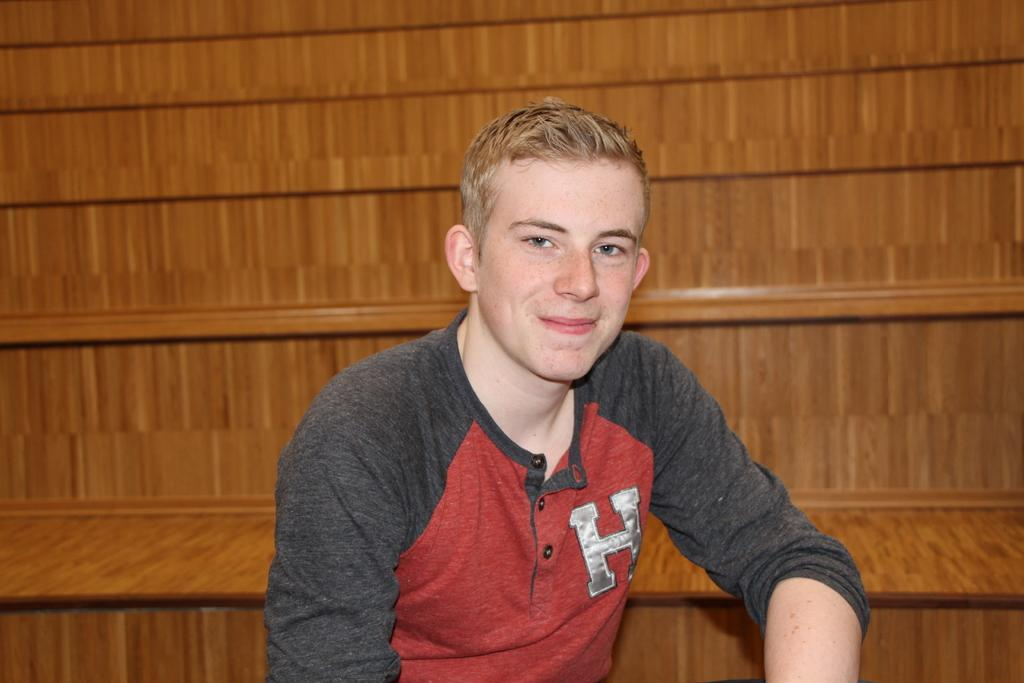What is happening in the image? There is a person in the image who is smiling and posing for a photo. Can you describe the person's expression? The person is smiling in the image. What can be seen in the background of the image? There is a wooden structure in the background of the image that resembles stairs. How many oranges are being held by the person in the image? There are no oranges present in the image. What type of power is being generated by the person in the image? The person in the image is not generating any power; they are posing for a photo and smiling. 